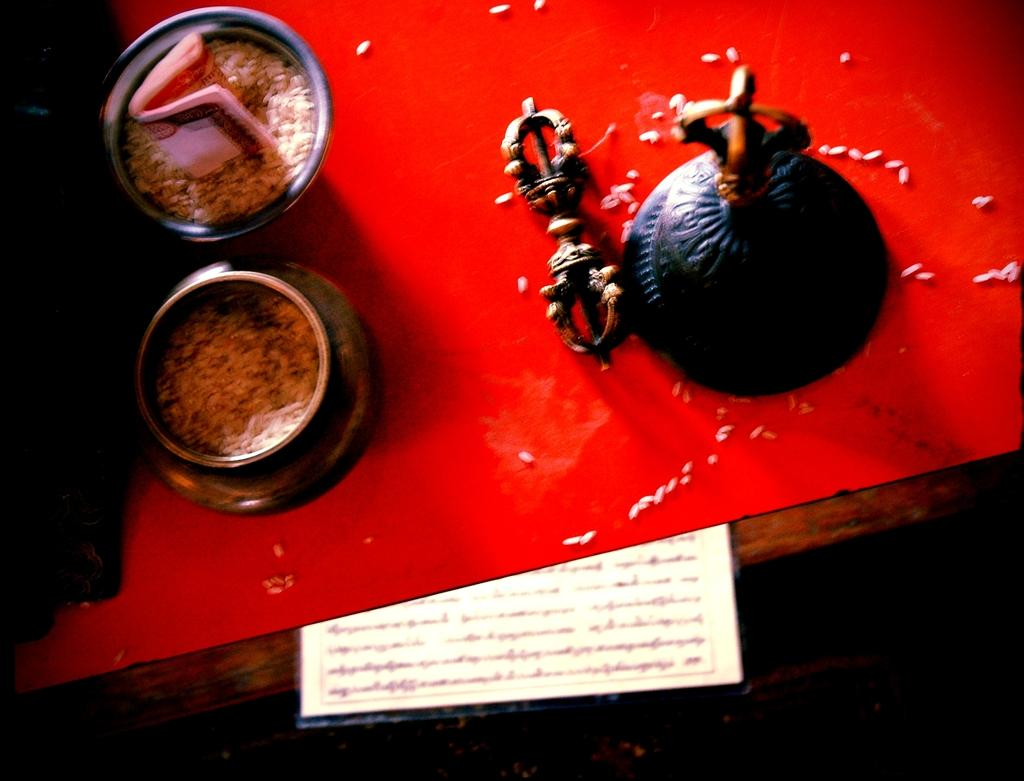What is inside the vessels in the image? There are grains in the vessels in the image. What type of object contains text in the image? There is a paper with text in the image. Can you describe the decorative element in the image? Unfortunately, the provided facts do not give enough information to describe the decorative element in the image. What type of instrument is being played by the head in the image? There is no head or instrument present in the image. 